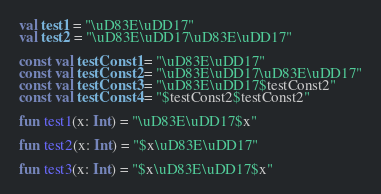Convert code to text. <code><loc_0><loc_0><loc_500><loc_500><_Kotlin_>val test1 = "\uD83E\uDD17"
val test2 = "\uD83E\uDD17\uD83E\uDD17"

const val testConst1 = "\uD83E\uDD17"
const val testConst2 = "\uD83E\uDD17\uD83E\uDD17"
const val testConst3 = "\uD83E\uDD17$testConst2"
const val testConst4 = "$testConst2$testConst2"

fun test1(x: Int) = "\uD83E\uDD17$x"

fun test2(x: Int) = "$x\uD83E\uDD17"

fun test3(x: Int) = "$x\uD83E\uDD17$x"</code> 